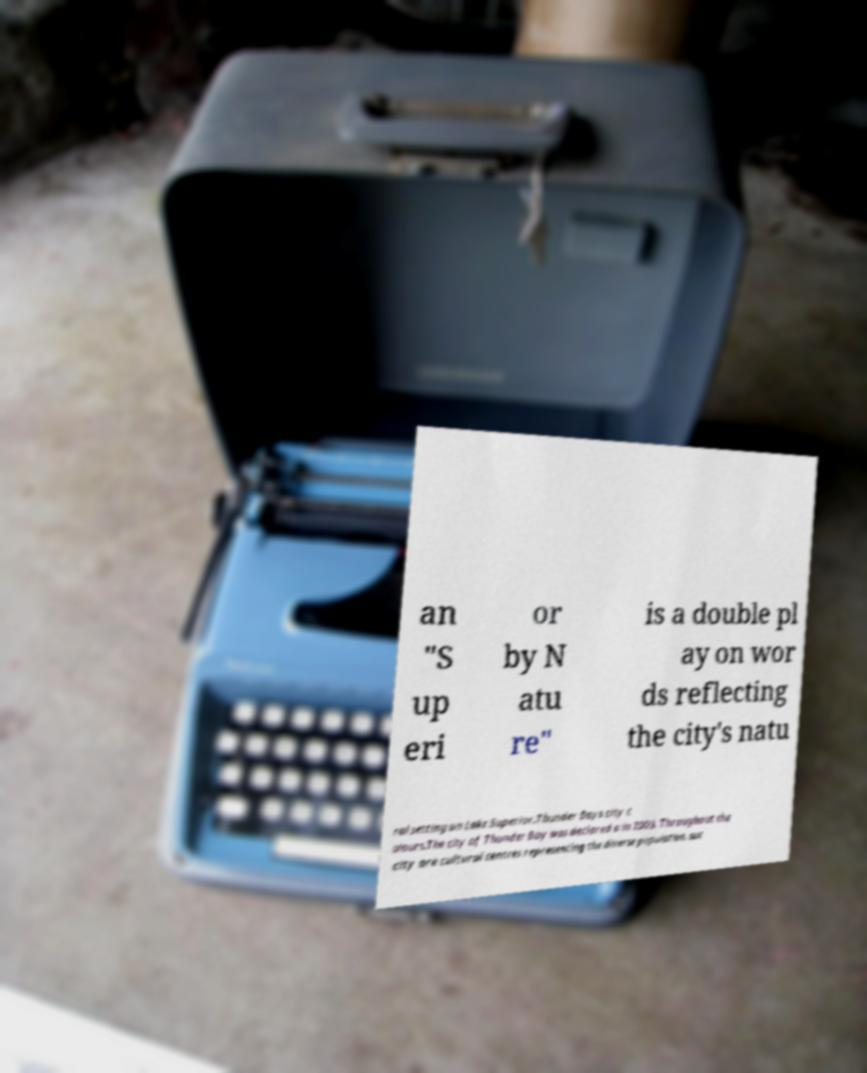There's text embedded in this image that I need extracted. Can you transcribe it verbatim? an "S up eri or by N atu re" is a double pl ay on wor ds reflecting the city's natu ral setting on Lake Superior.Thunder Bays city c olours.The city of Thunder Bay was declared a in 2003. Throughout the city are cultural centres representing the diverse population, suc 